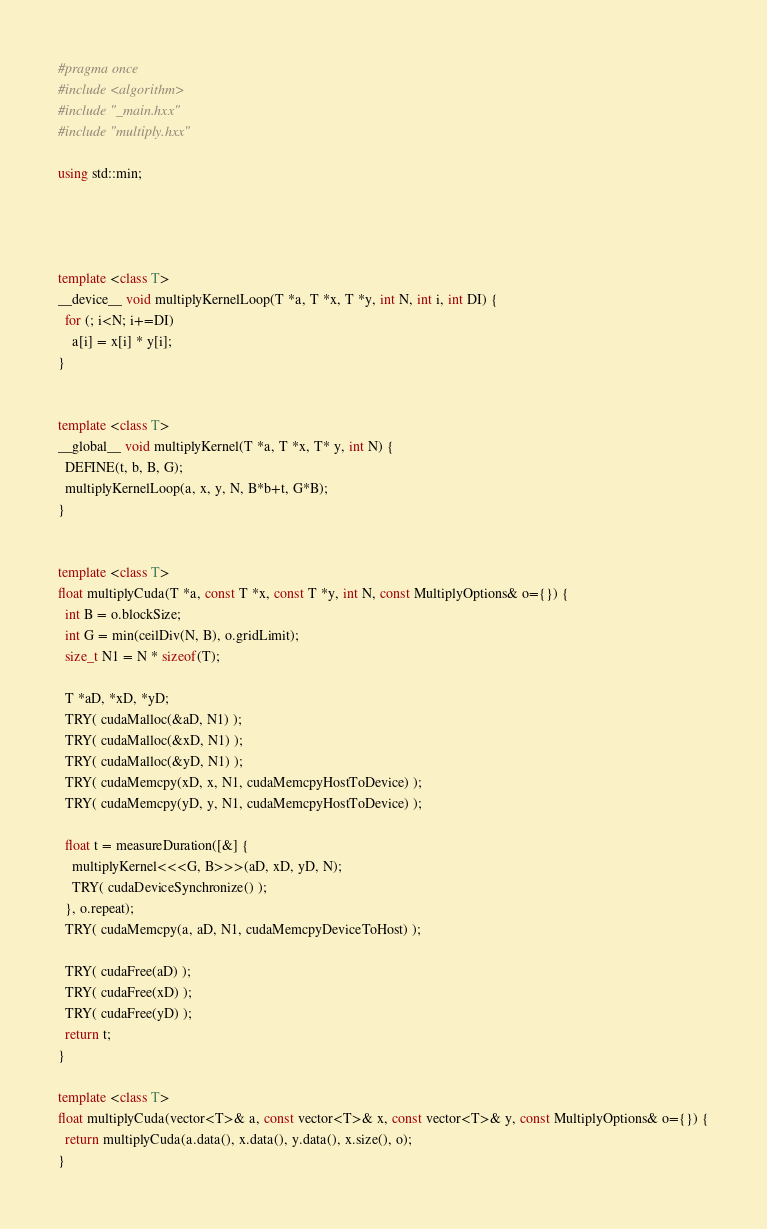Convert code to text. <code><loc_0><loc_0><loc_500><loc_500><_C++_>#pragma once
#include <algorithm>
#include "_main.hxx"
#include "multiply.hxx"

using std::min;




template <class T>
__device__ void multiplyKernelLoop(T *a, T *x, T *y, int N, int i, int DI) {
  for (; i<N; i+=DI)
    a[i] = x[i] * y[i];
}


template <class T>
__global__ void multiplyKernel(T *a, T *x, T* y, int N) {
  DEFINE(t, b, B, G);
  multiplyKernelLoop(a, x, y, N, B*b+t, G*B);
}


template <class T>
float multiplyCuda(T *a, const T *x, const T *y, int N, const MultiplyOptions& o={}) {
  int B = o.blockSize;
  int G = min(ceilDiv(N, B), o.gridLimit);
  size_t N1 = N * sizeof(T);

  T *aD, *xD, *yD;
  TRY( cudaMalloc(&aD, N1) );
  TRY( cudaMalloc(&xD, N1) );
  TRY( cudaMalloc(&yD, N1) );
  TRY( cudaMemcpy(xD, x, N1, cudaMemcpyHostToDevice) );
  TRY( cudaMemcpy(yD, y, N1, cudaMemcpyHostToDevice) );

  float t = measureDuration([&] {
    multiplyKernel<<<G, B>>>(aD, xD, yD, N);
    TRY( cudaDeviceSynchronize() );
  }, o.repeat);
  TRY( cudaMemcpy(a, aD, N1, cudaMemcpyDeviceToHost) );

  TRY( cudaFree(aD) );
  TRY( cudaFree(xD) );
  TRY( cudaFree(yD) );
  return t;
}

template <class T>
float multiplyCuda(vector<T>& a, const vector<T>& x, const vector<T>& y, const MultiplyOptions& o={}) {
  return multiplyCuda(a.data(), x.data(), y.data(), x.size(), o);
}
</code> 